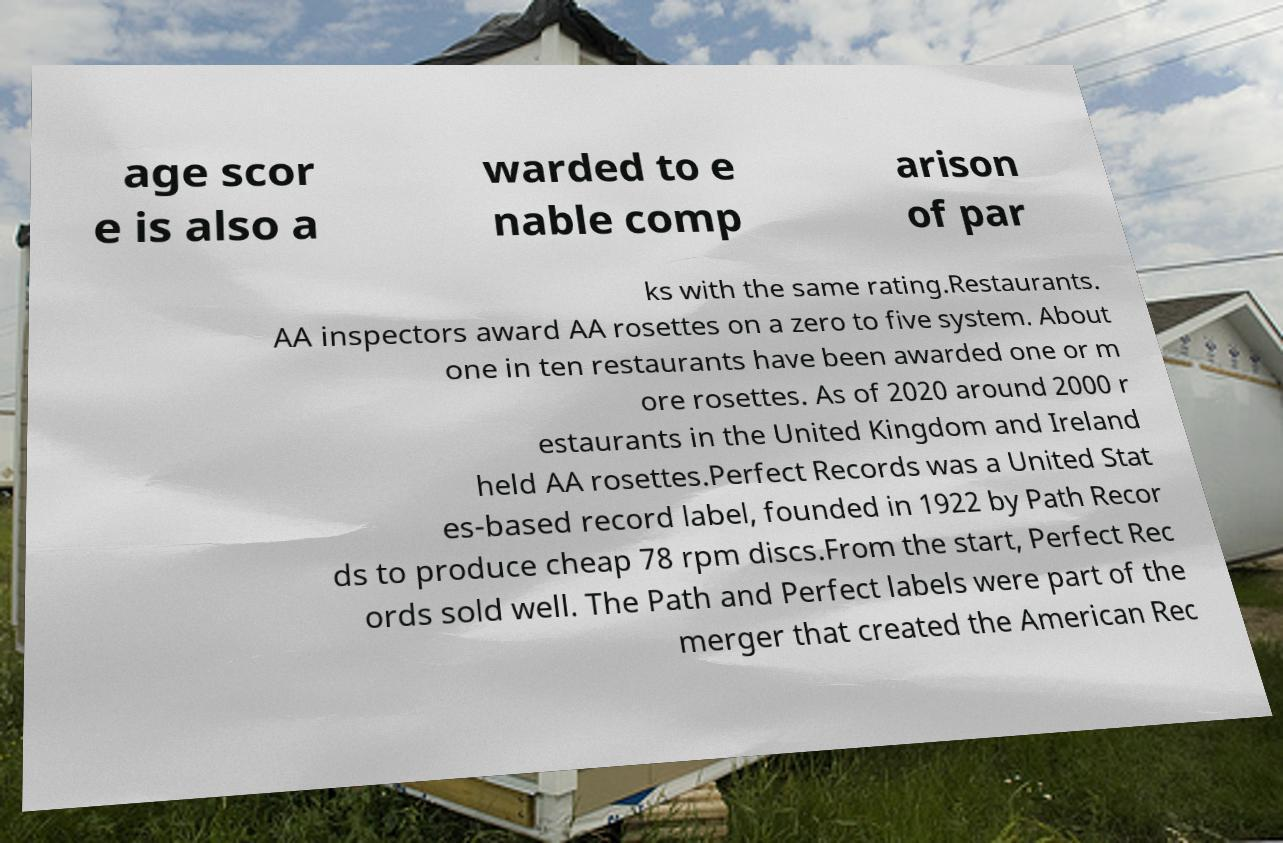Could you extract and type out the text from this image? age scor e is also a warded to e nable comp arison of par ks with the same rating.Restaurants. AA inspectors award AA rosettes on a zero to five system. About one in ten restaurants have been awarded one or m ore rosettes. As of 2020 around 2000 r estaurants in the United Kingdom and Ireland held AA rosettes.Perfect Records was a United Stat es-based record label, founded in 1922 by Path Recor ds to produce cheap 78 rpm discs.From the start, Perfect Rec ords sold well. The Path and Perfect labels were part of the merger that created the American Rec 